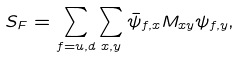Convert formula to latex. <formula><loc_0><loc_0><loc_500><loc_500>S _ { F } = \sum _ { f = u , d } \sum _ { x , y } \bar { \psi } _ { f , x } M _ { x y } \psi _ { f , y } ,</formula> 